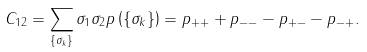Convert formula to latex. <formula><loc_0><loc_0><loc_500><loc_500>C _ { 1 2 } = \sum _ { \{ \sigma _ { k } \} } \sigma _ { 1 } \sigma _ { 2 } p \left ( \{ \sigma _ { k } \} \right ) = p _ { + + } + p _ { - - } - p _ { + - } - p _ { - + } .</formula> 